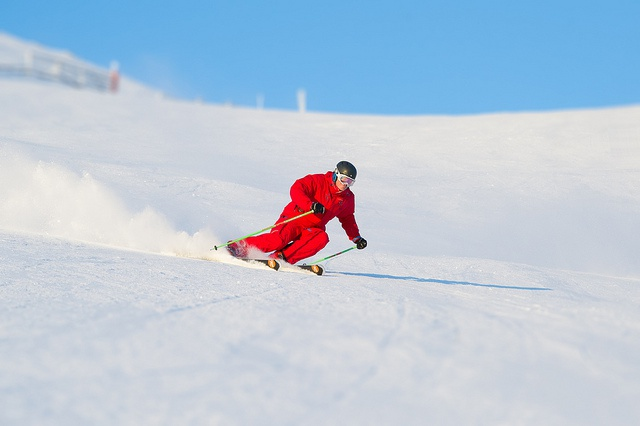Describe the objects in this image and their specific colors. I can see people in lightblue, red, brown, maroon, and lightgray tones and skis in lightblue, black, lightgray, gray, and darkgray tones in this image. 